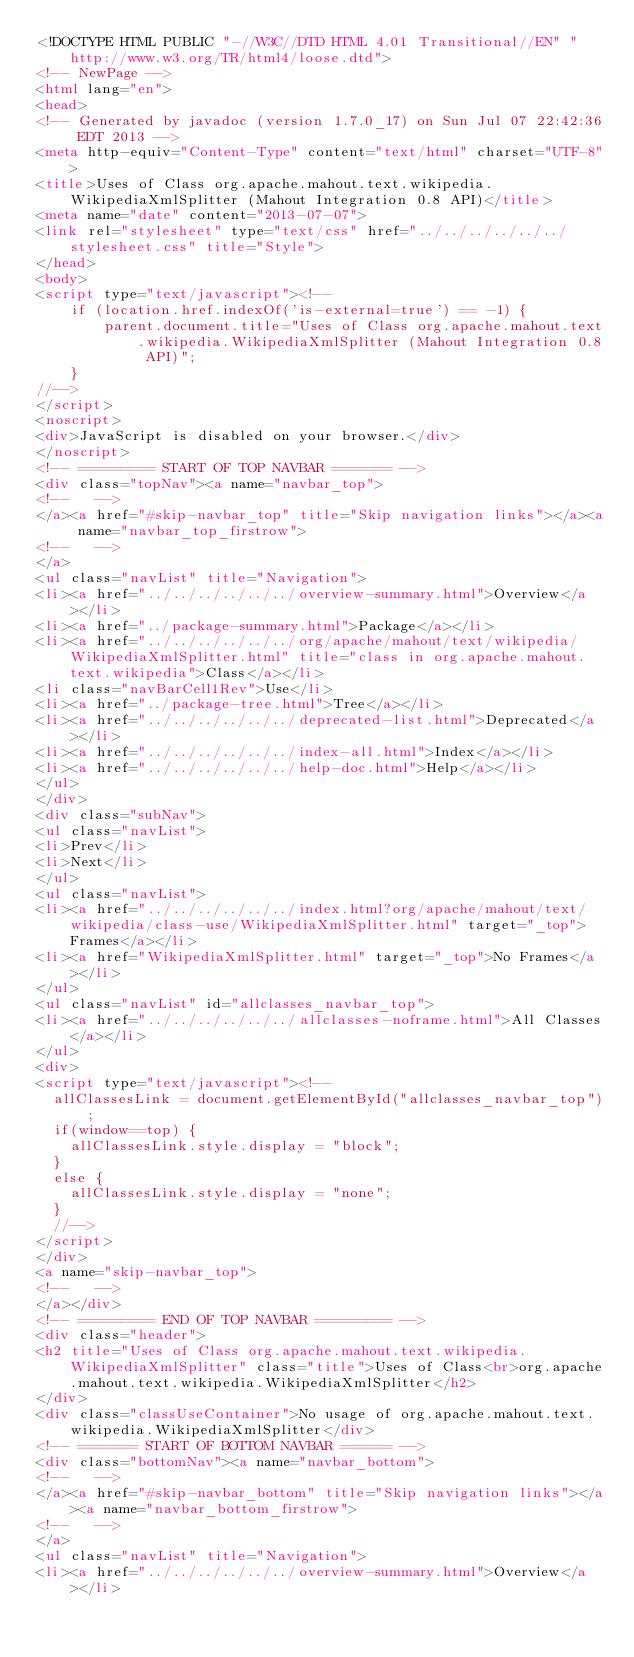Convert code to text. <code><loc_0><loc_0><loc_500><loc_500><_HTML_><!DOCTYPE HTML PUBLIC "-//W3C//DTD HTML 4.01 Transitional//EN" "http://www.w3.org/TR/html4/loose.dtd">
<!-- NewPage -->
<html lang="en">
<head>
<!-- Generated by javadoc (version 1.7.0_17) on Sun Jul 07 22:42:36 EDT 2013 -->
<meta http-equiv="Content-Type" content="text/html" charset="UTF-8">
<title>Uses of Class org.apache.mahout.text.wikipedia.WikipediaXmlSplitter (Mahout Integration 0.8 API)</title>
<meta name="date" content="2013-07-07">
<link rel="stylesheet" type="text/css" href="../../../../../../stylesheet.css" title="Style">
</head>
<body>
<script type="text/javascript"><!--
    if (location.href.indexOf('is-external=true') == -1) {
        parent.document.title="Uses of Class org.apache.mahout.text.wikipedia.WikipediaXmlSplitter (Mahout Integration 0.8 API)";
    }
//-->
</script>
<noscript>
<div>JavaScript is disabled on your browser.</div>
</noscript>
<!-- ========= START OF TOP NAVBAR ======= -->
<div class="topNav"><a name="navbar_top">
<!--   -->
</a><a href="#skip-navbar_top" title="Skip navigation links"></a><a name="navbar_top_firstrow">
<!--   -->
</a>
<ul class="navList" title="Navigation">
<li><a href="../../../../../../overview-summary.html">Overview</a></li>
<li><a href="../package-summary.html">Package</a></li>
<li><a href="../../../../../../org/apache/mahout/text/wikipedia/WikipediaXmlSplitter.html" title="class in org.apache.mahout.text.wikipedia">Class</a></li>
<li class="navBarCell1Rev">Use</li>
<li><a href="../package-tree.html">Tree</a></li>
<li><a href="../../../../../../deprecated-list.html">Deprecated</a></li>
<li><a href="../../../../../../index-all.html">Index</a></li>
<li><a href="../../../../../../help-doc.html">Help</a></li>
</ul>
</div>
<div class="subNav">
<ul class="navList">
<li>Prev</li>
<li>Next</li>
</ul>
<ul class="navList">
<li><a href="../../../../../../index.html?org/apache/mahout/text/wikipedia/class-use/WikipediaXmlSplitter.html" target="_top">Frames</a></li>
<li><a href="WikipediaXmlSplitter.html" target="_top">No Frames</a></li>
</ul>
<ul class="navList" id="allclasses_navbar_top">
<li><a href="../../../../../../allclasses-noframe.html">All Classes</a></li>
</ul>
<div>
<script type="text/javascript"><!--
  allClassesLink = document.getElementById("allclasses_navbar_top");
  if(window==top) {
    allClassesLink.style.display = "block";
  }
  else {
    allClassesLink.style.display = "none";
  }
  //-->
</script>
</div>
<a name="skip-navbar_top">
<!--   -->
</a></div>
<!-- ========= END OF TOP NAVBAR ========= -->
<div class="header">
<h2 title="Uses of Class org.apache.mahout.text.wikipedia.WikipediaXmlSplitter" class="title">Uses of Class<br>org.apache.mahout.text.wikipedia.WikipediaXmlSplitter</h2>
</div>
<div class="classUseContainer">No usage of org.apache.mahout.text.wikipedia.WikipediaXmlSplitter</div>
<!-- ======= START OF BOTTOM NAVBAR ====== -->
<div class="bottomNav"><a name="navbar_bottom">
<!--   -->
</a><a href="#skip-navbar_bottom" title="Skip navigation links"></a><a name="navbar_bottom_firstrow">
<!--   -->
</a>
<ul class="navList" title="Navigation">
<li><a href="../../../../../../overview-summary.html">Overview</a></li></code> 